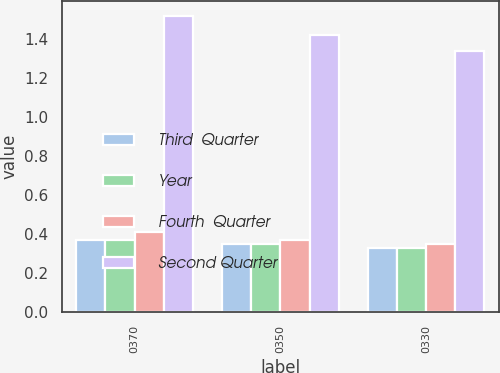Convert chart to OTSL. <chart><loc_0><loc_0><loc_500><loc_500><stacked_bar_chart><ecel><fcel>0370<fcel>0350<fcel>0330<nl><fcel>Third  Quarter<fcel>0.37<fcel>0.35<fcel>0.33<nl><fcel>Year<fcel>0.37<fcel>0.35<fcel>0.33<nl><fcel>Fourth  Quarter<fcel>0.41<fcel>0.37<fcel>0.35<nl><fcel>Second Quarter<fcel>1.52<fcel>1.42<fcel>1.34<nl></chart> 